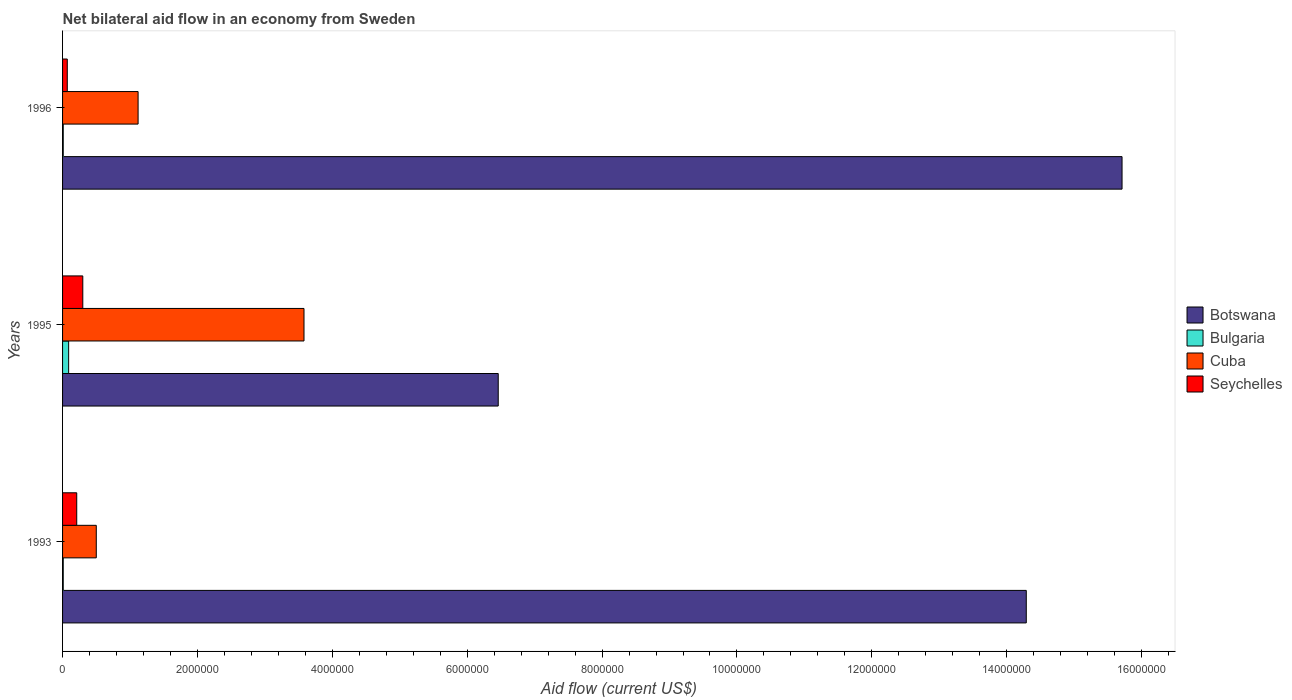How many groups of bars are there?
Keep it short and to the point. 3. Are the number of bars per tick equal to the number of legend labels?
Keep it short and to the point. Yes. How many bars are there on the 3rd tick from the top?
Offer a terse response. 4. What is the label of the 1st group of bars from the top?
Provide a succinct answer. 1996. Across all years, what is the maximum net bilateral aid flow in Botswana?
Make the answer very short. 1.57e+07. In which year was the net bilateral aid flow in Seychelles maximum?
Your answer should be compact. 1995. What is the total net bilateral aid flow in Cuba in the graph?
Your response must be concise. 5.20e+06. What is the difference between the net bilateral aid flow in Bulgaria in 1995 and that in 1996?
Your response must be concise. 8.00e+04. What is the difference between the net bilateral aid flow in Seychelles in 1993 and the net bilateral aid flow in Botswana in 1996?
Provide a succinct answer. -1.55e+07. What is the average net bilateral aid flow in Botswana per year?
Keep it short and to the point. 1.22e+07. In the year 1995, what is the difference between the net bilateral aid flow in Botswana and net bilateral aid flow in Bulgaria?
Make the answer very short. 6.37e+06. In how many years, is the net bilateral aid flow in Bulgaria greater than 5200000 US$?
Make the answer very short. 0. What is the ratio of the net bilateral aid flow in Cuba in 1993 to that in 1995?
Your answer should be very brief. 0.14. What is the difference between the highest and the second highest net bilateral aid flow in Cuba?
Your response must be concise. 2.46e+06. What is the difference between the highest and the lowest net bilateral aid flow in Cuba?
Provide a short and direct response. 3.08e+06. Is the sum of the net bilateral aid flow in Cuba in 1995 and 1996 greater than the maximum net bilateral aid flow in Botswana across all years?
Make the answer very short. No. Is it the case that in every year, the sum of the net bilateral aid flow in Botswana and net bilateral aid flow in Cuba is greater than the sum of net bilateral aid flow in Seychelles and net bilateral aid flow in Bulgaria?
Your answer should be compact. Yes. What does the 2nd bar from the top in 1993 represents?
Provide a succinct answer. Cuba. What does the 2nd bar from the bottom in 1993 represents?
Offer a terse response. Bulgaria. How many bars are there?
Your answer should be very brief. 12. Are all the bars in the graph horizontal?
Offer a terse response. Yes. What is the difference between two consecutive major ticks on the X-axis?
Keep it short and to the point. 2.00e+06. Are the values on the major ticks of X-axis written in scientific E-notation?
Provide a short and direct response. No. What is the title of the graph?
Offer a terse response. Net bilateral aid flow in an economy from Sweden. Does "Liberia" appear as one of the legend labels in the graph?
Offer a terse response. No. What is the label or title of the Y-axis?
Provide a succinct answer. Years. What is the Aid flow (current US$) in Botswana in 1993?
Provide a succinct answer. 1.43e+07. What is the Aid flow (current US$) of Seychelles in 1993?
Your answer should be very brief. 2.10e+05. What is the Aid flow (current US$) in Botswana in 1995?
Provide a succinct answer. 6.46e+06. What is the Aid flow (current US$) in Bulgaria in 1995?
Provide a short and direct response. 9.00e+04. What is the Aid flow (current US$) of Cuba in 1995?
Provide a short and direct response. 3.58e+06. What is the Aid flow (current US$) in Botswana in 1996?
Offer a very short reply. 1.57e+07. What is the Aid flow (current US$) of Bulgaria in 1996?
Your response must be concise. 10000. What is the Aid flow (current US$) of Cuba in 1996?
Give a very brief answer. 1.12e+06. What is the Aid flow (current US$) in Seychelles in 1996?
Give a very brief answer. 7.00e+04. Across all years, what is the maximum Aid flow (current US$) in Botswana?
Your response must be concise. 1.57e+07. Across all years, what is the maximum Aid flow (current US$) of Bulgaria?
Your answer should be compact. 9.00e+04. Across all years, what is the maximum Aid flow (current US$) in Cuba?
Ensure brevity in your answer.  3.58e+06. Across all years, what is the minimum Aid flow (current US$) in Botswana?
Your response must be concise. 6.46e+06. Across all years, what is the minimum Aid flow (current US$) of Cuba?
Offer a very short reply. 5.00e+05. What is the total Aid flow (current US$) in Botswana in the graph?
Give a very brief answer. 3.65e+07. What is the total Aid flow (current US$) of Cuba in the graph?
Offer a terse response. 5.20e+06. What is the total Aid flow (current US$) of Seychelles in the graph?
Offer a terse response. 5.80e+05. What is the difference between the Aid flow (current US$) in Botswana in 1993 and that in 1995?
Give a very brief answer. 7.83e+06. What is the difference between the Aid flow (current US$) in Bulgaria in 1993 and that in 1995?
Your answer should be compact. -8.00e+04. What is the difference between the Aid flow (current US$) of Cuba in 1993 and that in 1995?
Your answer should be compact. -3.08e+06. What is the difference between the Aid flow (current US$) in Botswana in 1993 and that in 1996?
Offer a terse response. -1.42e+06. What is the difference between the Aid flow (current US$) of Bulgaria in 1993 and that in 1996?
Your answer should be very brief. 0. What is the difference between the Aid flow (current US$) of Cuba in 1993 and that in 1996?
Your answer should be very brief. -6.20e+05. What is the difference between the Aid flow (current US$) in Seychelles in 1993 and that in 1996?
Provide a succinct answer. 1.40e+05. What is the difference between the Aid flow (current US$) of Botswana in 1995 and that in 1996?
Offer a very short reply. -9.25e+06. What is the difference between the Aid flow (current US$) of Cuba in 1995 and that in 1996?
Give a very brief answer. 2.46e+06. What is the difference between the Aid flow (current US$) in Seychelles in 1995 and that in 1996?
Your answer should be very brief. 2.30e+05. What is the difference between the Aid flow (current US$) of Botswana in 1993 and the Aid flow (current US$) of Bulgaria in 1995?
Make the answer very short. 1.42e+07. What is the difference between the Aid flow (current US$) of Botswana in 1993 and the Aid flow (current US$) of Cuba in 1995?
Your response must be concise. 1.07e+07. What is the difference between the Aid flow (current US$) in Botswana in 1993 and the Aid flow (current US$) in Seychelles in 1995?
Provide a succinct answer. 1.40e+07. What is the difference between the Aid flow (current US$) of Bulgaria in 1993 and the Aid flow (current US$) of Cuba in 1995?
Keep it short and to the point. -3.57e+06. What is the difference between the Aid flow (current US$) of Bulgaria in 1993 and the Aid flow (current US$) of Seychelles in 1995?
Give a very brief answer. -2.90e+05. What is the difference between the Aid flow (current US$) of Botswana in 1993 and the Aid flow (current US$) of Bulgaria in 1996?
Give a very brief answer. 1.43e+07. What is the difference between the Aid flow (current US$) of Botswana in 1993 and the Aid flow (current US$) of Cuba in 1996?
Provide a short and direct response. 1.32e+07. What is the difference between the Aid flow (current US$) of Botswana in 1993 and the Aid flow (current US$) of Seychelles in 1996?
Offer a very short reply. 1.42e+07. What is the difference between the Aid flow (current US$) of Bulgaria in 1993 and the Aid flow (current US$) of Cuba in 1996?
Provide a short and direct response. -1.11e+06. What is the difference between the Aid flow (current US$) of Cuba in 1993 and the Aid flow (current US$) of Seychelles in 1996?
Your response must be concise. 4.30e+05. What is the difference between the Aid flow (current US$) of Botswana in 1995 and the Aid flow (current US$) of Bulgaria in 1996?
Ensure brevity in your answer.  6.45e+06. What is the difference between the Aid flow (current US$) of Botswana in 1995 and the Aid flow (current US$) of Cuba in 1996?
Provide a short and direct response. 5.34e+06. What is the difference between the Aid flow (current US$) of Botswana in 1995 and the Aid flow (current US$) of Seychelles in 1996?
Provide a short and direct response. 6.39e+06. What is the difference between the Aid flow (current US$) in Bulgaria in 1995 and the Aid flow (current US$) in Cuba in 1996?
Provide a succinct answer. -1.03e+06. What is the difference between the Aid flow (current US$) in Cuba in 1995 and the Aid flow (current US$) in Seychelles in 1996?
Provide a succinct answer. 3.51e+06. What is the average Aid flow (current US$) in Botswana per year?
Provide a short and direct response. 1.22e+07. What is the average Aid flow (current US$) of Bulgaria per year?
Keep it short and to the point. 3.67e+04. What is the average Aid flow (current US$) in Cuba per year?
Your response must be concise. 1.73e+06. What is the average Aid flow (current US$) of Seychelles per year?
Provide a short and direct response. 1.93e+05. In the year 1993, what is the difference between the Aid flow (current US$) of Botswana and Aid flow (current US$) of Bulgaria?
Your answer should be very brief. 1.43e+07. In the year 1993, what is the difference between the Aid flow (current US$) in Botswana and Aid flow (current US$) in Cuba?
Ensure brevity in your answer.  1.38e+07. In the year 1993, what is the difference between the Aid flow (current US$) in Botswana and Aid flow (current US$) in Seychelles?
Make the answer very short. 1.41e+07. In the year 1993, what is the difference between the Aid flow (current US$) of Bulgaria and Aid flow (current US$) of Cuba?
Your answer should be very brief. -4.90e+05. In the year 1993, what is the difference between the Aid flow (current US$) of Bulgaria and Aid flow (current US$) of Seychelles?
Ensure brevity in your answer.  -2.00e+05. In the year 1993, what is the difference between the Aid flow (current US$) in Cuba and Aid flow (current US$) in Seychelles?
Your response must be concise. 2.90e+05. In the year 1995, what is the difference between the Aid flow (current US$) in Botswana and Aid flow (current US$) in Bulgaria?
Ensure brevity in your answer.  6.37e+06. In the year 1995, what is the difference between the Aid flow (current US$) in Botswana and Aid flow (current US$) in Cuba?
Your answer should be very brief. 2.88e+06. In the year 1995, what is the difference between the Aid flow (current US$) of Botswana and Aid flow (current US$) of Seychelles?
Your answer should be compact. 6.16e+06. In the year 1995, what is the difference between the Aid flow (current US$) in Bulgaria and Aid flow (current US$) in Cuba?
Make the answer very short. -3.49e+06. In the year 1995, what is the difference between the Aid flow (current US$) of Bulgaria and Aid flow (current US$) of Seychelles?
Provide a short and direct response. -2.10e+05. In the year 1995, what is the difference between the Aid flow (current US$) in Cuba and Aid flow (current US$) in Seychelles?
Provide a short and direct response. 3.28e+06. In the year 1996, what is the difference between the Aid flow (current US$) of Botswana and Aid flow (current US$) of Bulgaria?
Make the answer very short. 1.57e+07. In the year 1996, what is the difference between the Aid flow (current US$) in Botswana and Aid flow (current US$) in Cuba?
Your response must be concise. 1.46e+07. In the year 1996, what is the difference between the Aid flow (current US$) in Botswana and Aid flow (current US$) in Seychelles?
Your answer should be compact. 1.56e+07. In the year 1996, what is the difference between the Aid flow (current US$) in Bulgaria and Aid flow (current US$) in Cuba?
Keep it short and to the point. -1.11e+06. In the year 1996, what is the difference between the Aid flow (current US$) of Cuba and Aid flow (current US$) of Seychelles?
Give a very brief answer. 1.05e+06. What is the ratio of the Aid flow (current US$) of Botswana in 1993 to that in 1995?
Provide a short and direct response. 2.21. What is the ratio of the Aid flow (current US$) in Cuba in 1993 to that in 1995?
Give a very brief answer. 0.14. What is the ratio of the Aid flow (current US$) in Seychelles in 1993 to that in 1995?
Give a very brief answer. 0.7. What is the ratio of the Aid flow (current US$) in Botswana in 1993 to that in 1996?
Give a very brief answer. 0.91. What is the ratio of the Aid flow (current US$) in Cuba in 1993 to that in 1996?
Make the answer very short. 0.45. What is the ratio of the Aid flow (current US$) in Botswana in 1995 to that in 1996?
Your response must be concise. 0.41. What is the ratio of the Aid flow (current US$) in Cuba in 1995 to that in 1996?
Offer a very short reply. 3.2. What is the ratio of the Aid flow (current US$) in Seychelles in 1995 to that in 1996?
Ensure brevity in your answer.  4.29. What is the difference between the highest and the second highest Aid flow (current US$) of Botswana?
Give a very brief answer. 1.42e+06. What is the difference between the highest and the second highest Aid flow (current US$) in Bulgaria?
Keep it short and to the point. 8.00e+04. What is the difference between the highest and the second highest Aid flow (current US$) of Cuba?
Your response must be concise. 2.46e+06. What is the difference between the highest and the second highest Aid flow (current US$) of Seychelles?
Offer a very short reply. 9.00e+04. What is the difference between the highest and the lowest Aid flow (current US$) in Botswana?
Your answer should be compact. 9.25e+06. What is the difference between the highest and the lowest Aid flow (current US$) of Cuba?
Your answer should be very brief. 3.08e+06. What is the difference between the highest and the lowest Aid flow (current US$) of Seychelles?
Make the answer very short. 2.30e+05. 